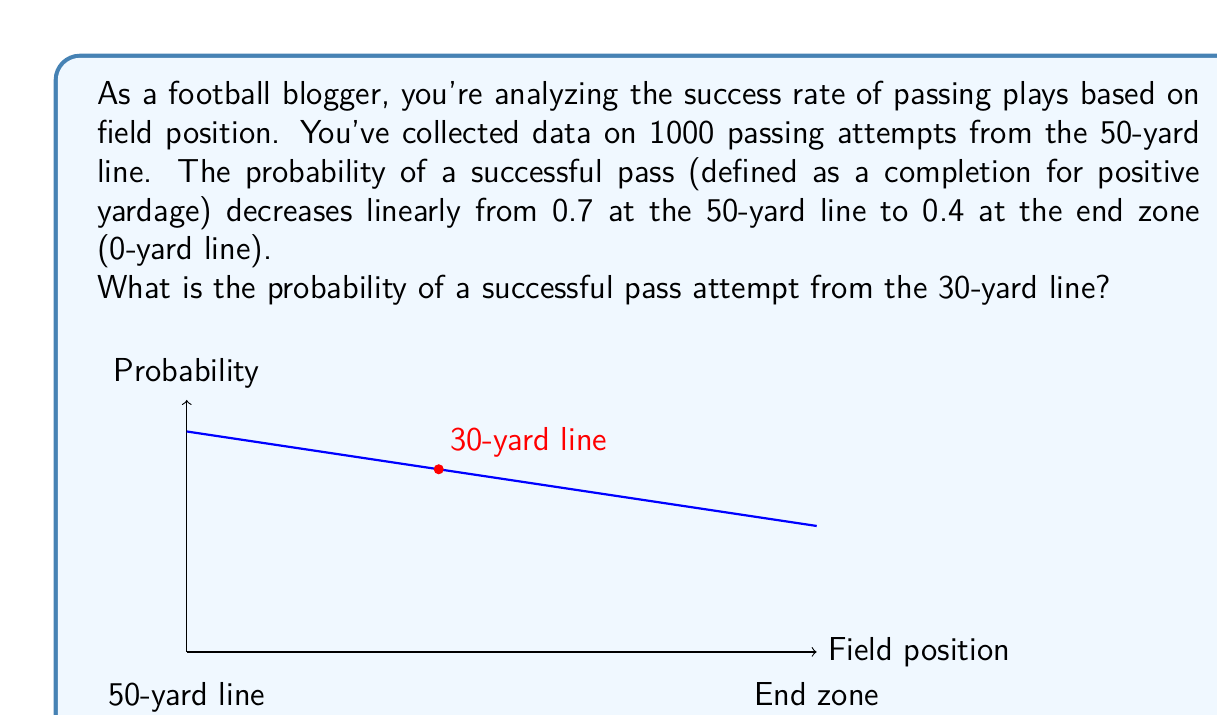Give your solution to this math problem. Let's approach this step-by-step:

1) First, we need to understand the linear relationship between field position and pass success probability.

2) We're given two points:
   - At the 50-yard line (x = 0), probability is 0.7
   - At the 0-yard line (x = 50), probability is 0.4

3) We can use the point-slope form of a line to find the equation:
   $y - y_1 = m(x - x_1)$

4) The slope (m) is:
   $m = \frac{y_2 - y_1}{x_2 - x_1} = \frac{0.4 - 0.7}{50 - 0} = -\frac{0.3}{50} = -0.006$

5) Using the point (0, 0.7), our equation is:
   $y - 0.7 = -0.006(x - 0)$

6) Simplifying:
   $y = -0.006x + 0.7$

7) Now, we want to find the probability at the 30-yard line. This is 20 yards from the 50-yard line, so x = 20.

8) Plugging in x = 20:
   $y = -0.006(20) + 0.7$
   $y = -0.12 + 0.7 = 0.58$

Therefore, the probability of a successful pass at the 30-yard line is 0.58 or 58%.
Answer: 0.58 